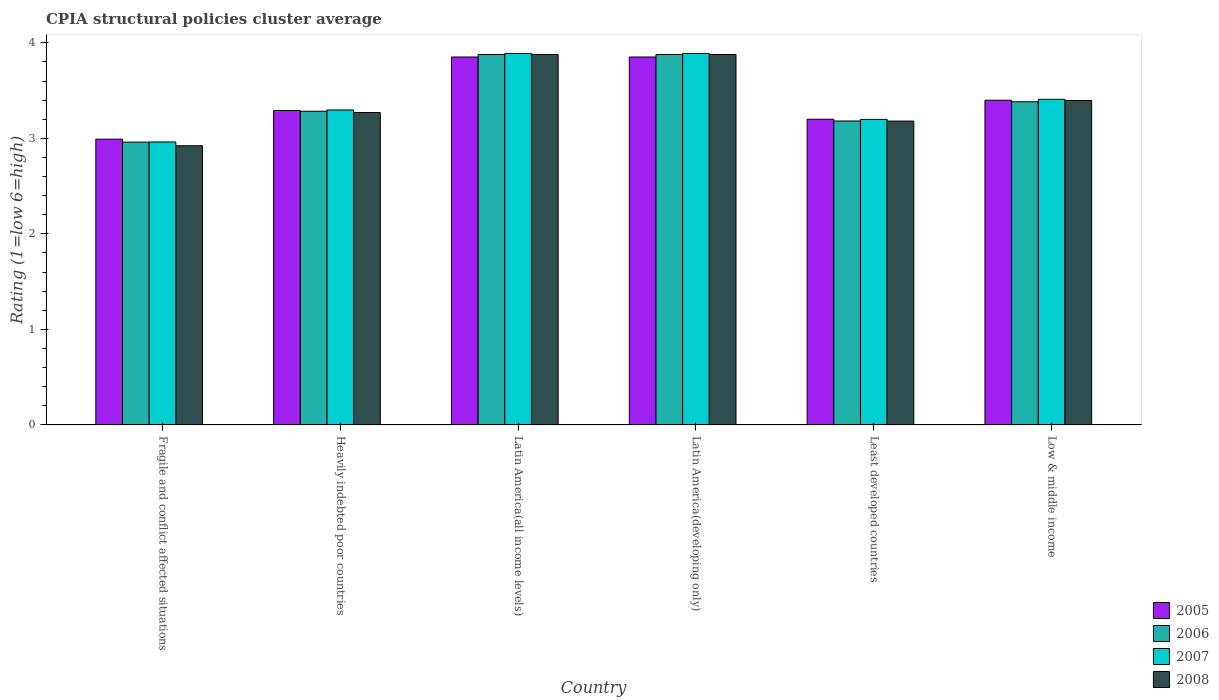How many different coloured bars are there?
Offer a terse response. 4. How many groups of bars are there?
Offer a very short reply. 6. Are the number of bars on each tick of the X-axis equal?
Ensure brevity in your answer.  Yes. How many bars are there on the 1st tick from the right?
Keep it short and to the point. 4. What is the label of the 4th group of bars from the left?
Make the answer very short. Latin America(developing only). In how many cases, is the number of bars for a given country not equal to the number of legend labels?
Provide a short and direct response. 0. What is the CPIA rating in 2007 in Latin America(developing only)?
Provide a short and direct response. 3.89. Across all countries, what is the maximum CPIA rating in 2006?
Offer a terse response. 3.88. Across all countries, what is the minimum CPIA rating in 2005?
Make the answer very short. 2.99. In which country was the CPIA rating in 2008 maximum?
Ensure brevity in your answer.  Latin America(all income levels). In which country was the CPIA rating in 2008 minimum?
Offer a very short reply. Fragile and conflict affected situations. What is the total CPIA rating in 2008 in the graph?
Ensure brevity in your answer.  20.53. What is the difference between the CPIA rating in 2006 in Fragile and conflict affected situations and that in Latin America(all income levels)?
Offer a terse response. -0.92. What is the difference between the CPIA rating in 2005 in Low & middle income and the CPIA rating in 2006 in Least developed countries?
Keep it short and to the point. 0.22. What is the average CPIA rating in 2007 per country?
Your answer should be very brief. 3.44. What is the difference between the CPIA rating of/in 2007 and CPIA rating of/in 2008 in Low & middle income?
Provide a succinct answer. 0.01. In how many countries, is the CPIA rating in 2008 greater than 2.2?
Make the answer very short. 6. What is the ratio of the CPIA rating in 2008 in Heavily indebted poor countries to that in Latin America(developing only)?
Offer a terse response. 0.84. Is the CPIA rating in 2008 in Least developed countries less than that in Low & middle income?
Your answer should be compact. Yes. What is the difference between the highest and the second highest CPIA rating in 2006?
Make the answer very short. -0.49. What is the difference between the highest and the lowest CPIA rating in 2007?
Offer a terse response. 0.93. In how many countries, is the CPIA rating in 2005 greater than the average CPIA rating in 2005 taken over all countries?
Offer a terse response. 2. What does the 2nd bar from the right in Heavily indebted poor countries represents?
Your answer should be very brief. 2007. How many bars are there?
Ensure brevity in your answer.  24. How many countries are there in the graph?
Offer a terse response. 6. Are the values on the major ticks of Y-axis written in scientific E-notation?
Keep it short and to the point. No. Does the graph contain grids?
Your answer should be very brief. No. What is the title of the graph?
Make the answer very short. CPIA structural policies cluster average. Does "2000" appear as one of the legend labels in the graph?
Provide a succinct answer. No. What is the label or title of the Y-axis?
Your response must be concise. Rating (1=low 6=high). What is the Rating (1=low 6=high) in 2005 in Fragile and conflict affected situations?
Make the answer very short. 2.99. What is the Rating (1=low 6=high) of 2006 in Fragile and conflict affected situations?
Give a very brief answer. 2.96. What is the Rating (1=low 6=high) of 2007 in Fragile and conflict affected situations?
Ensure brevity in your answer.  2.96. What is the Rating (1=low 6=high) of 2008 in Fragile and conflict affected situations?
Offer a very short reply. 2.92. What is the Rating (1=low 6=high) of 2005 in Heavily indebted poor countries?
Provide a succinct answer. 3.29. What is the Rating (1=low 6=high) of 2006 in Heavily indebted poor countries?
Ensure brevity in your answer.  3.28. What is the Rating (1=low 6=high) in 2007 in Heavily indebted poor countries?
Ensure brevity in your answer.  3.3. What is the Rating (1=low 6=high) in 2008 in Heavily indebted poor countries?
Ensure brevity in your answer.  3.27. What is the Rating (1=low 6=high) of 2005 in Latin America(all income levels)?
Your answer should be very brief. 3.85. What is the Rating (1=low 6=high) of 2006 in Latin America(all income levels)?
Ensure brevity in your answer.  3.88. What is the Rating (1=low 6=high) in 2007 in Latin America(all income levels)?
Your response must be concise. 3.89. What is the Rating (1=low 6=high) of 2008 in Latin America(all income levels)?
Your answer should be compact. 3.88. What is the Rating (1=low 6=high) in 2005 in Latin America(developing only)?
Your answer should be very brief. 3.85. What is the Rating (1=low 6=high) in 2006 in Latin America(developing only)?
Ensure brevity in your answer.  3.88. What is the Rating (1=low 6=high) in 2007 in Latin America(developing only)?
Make the answer very short. 3.89. What is the Rating (1=low 6=high) of 2008 in Latin America(developing only)?
Your answer should be very brief. 3.88. What is the Rating (1=low 6=high) of 2006 in Least developed countries?
Give a very brief answer. 3.18. What is the Rating (1=low 6=high) of 2007 in Least developed countries?
Ensure brevity in your answer.  3.2. What is the Rating (1=low 6=high) of 2008 in Least developed countries?
Your response must be concise. 3.18. What is the Rating (1=low 6=high) in 2005 in Low & middle income?
Provide a short and direct response. 3.4. What is the Rating (1=low 6=high) in 2006 in Low & middle income?
Give a very brief answer. 3.38. What is the Rating (1=low 6=high) in 2007 in Low & middle income?
Give a very brief answer. 3.41. What is the Rating (1=low 6=high) in 2008 in Low & middle income?
Your answer should be compact. 3.4. Across all countries, what is the maximum Rating (1=low 6=high) of 2005?
Keep it short and to the point. 3.85. Across all countries, what is the maximum Rating (1=low 6=high) of 2006?
Give a very brief answer. 3.88. Across all countries, what is the maximum Rating (1=low 6=high) of 2007?
Keep it short and to the point. 3.89. Across all countries, what is the maximum Rating (1=low 6=high) in 2008?
Keep it short and to the point. 3.88. Across all countries, what is the minimum Rating (1=low 6=high) of 2005?
Your answer should be compact. 2.99. Across all countries, what is the minimum Rating (1=low 6=high) of 2006?
Offer a terse response. 2.96. Across all countries, what is the minimum Rating (1=low 6=high) of 2007?
Your response must be concise. 2.96. Across all countries, what is the minimum Rating (1=low 6=high) in 2008?
Give a very brief answer. 2.92. What is the total Rating (1=low 6=high) of 2005 in the graph?
Ensure brevity in your answer.  20.59. What is the total Rating (1=low 6=high) in 2006 in the graph?
Provide a succinct answer. 20.56. What is the total Rating (1=low 6=high) of 2007 in the graph?
Offer a very short reply. 20.64. What is the total Rating (1=low 6=high) of 2008 in the graph?
Give a very brief answer. 20.53. What is the difference between the Rating (1=low 6=high) of 2005 in Fragile and conflict affected situations and that in Heavily indebted poor countries?
Your answer should be very brief. -0.3. What is the difference between the Rating (1=low 6=high) in 2006 in Fragile and conflict affected situations and that in Heavily indebted poor countries?
Offer a terse response. -0.32. What is the difference between the Rating (1=low 6=high) of 2007 in Fragile and conflict affected situations and that in Heavily indebted poor countries?
Make the answer very short. -0.34. What is the difference between the Rating (1=low 6=high) of 2008 in Fragile and conflict affected situations and that in Heavily indebted poor countries?
Provide a short and direct response. -0.35. What is the difference between the Rating (1=low 6=high) in 2005 in Fragile and conflict affected situations and that in Latin America(all income levels)?
Your answer should be very brief. -0.86. What is the difference between the Rating (1=low 6=high) of 2006 in Fragile and conflict affected situations and that in Latin America(all income levels)?
Make the answer very short. -0.92. What is the difference between the Rating (1=low 6=high) of 2007 in Fragile and conflict affected situations and that in Latin America(all income levels)?
Your answer should be very brief. -0.93. What is the difference between the Rating (1=low 6=high) in 2008 in Fragile and conflict affected situations and that in Latin America(all income levels)?
Keep it short and to the point. -0.96. What is the difference between the Rating (1=low 6=high) of 2005 in Fragile and conflict affected situations and that in Latin America(developing only)?
Provide a succinct answer. -0.86. What is the difference between the Rating (1=low 6=high) of 2006 in Fragile and conflict affected situations and that in Latin America(developing only)?
Your answer should be very brief. -0.92. What is the difference between the Rating (1=low 6=high) in 2007 in Fragile and conflict affected situations and that in Latin America(developing only)?
Your response must be concise. -0.93. What is the difference between the Rating (1=low 6=high) of 2008 in Fragile and conflict affected situations and that in Latin America(developing only)?
Your answer should be very brief. -0.96. What is the difference between the Rating (1=low 6=high) in 2005 in Fragile and conflict affected situations and that in Least developed countries?
Provide a succinct answer. -0.21. What is the difference between the Rating (1=low 6=high) in 2006 in Fragile and conflict affected situations and that in Least developed countries?
Your response must be concise. -0.22. What is the difference between the Rating (1=low 6=high) of 2007 in Fragile and conflict affected situations and that in Least developed countries?
Your answer should be compact. -0.24. What is the difference between the Rating (1=low 6=high) in 2008 in Fragile and conflict affected situations and that in Least developed countries?
Provide a short and direct response. -0.26. What is the difference between the Rating (1=low 6=high) of 2005 in Fragile and conflict affected situations and that in Low & middle income?
Offer a very short reply. -0.41. What is the difference between the Rating (1=low 6=high) of 2006 in Fragile and conflict affected situations and that in Low & middle income?
Your answer should be compact. -0.42. What is the difference between the Rating (1=low 6=high) in 2007 in Fragile and conflict affected situations and that in Low & middle income?
Your response must be concise. -0.45. What is the difference between the Rating (1=low 6=high) of 2008 in Fragile and conflict affected situations and that in Low & middle income?
Your answer should be very brief. -0.47. What is the difference between the Rating (1=low 6=high) of 2005 in Heavily indebted poor countries and that in Latin America(all income levels)?
Provide a short and direct response. -0.56. What is the difference between the Rating (1=low 6=high) in 2006 in Heavily indebted poor countries and that in Latin America(all income levels)?
Your answer should be very brief. -0.59. What is the difference between the Rating (1=low 6=high) in 2007 in Heavily indebted poor countries and that in Latin America(all income levels)?
Keep it short and to the point. -0.59. What is the difference between the Rating (1=low 6=high) in 2008 in Heavily indebted poor countries and that in Latin America(all income levels)?
Your answer should be compact. -0.61. What is the difference between the Rating (1=low 6=high) in 2005 in Heavily indebted poor countries and that in Latin America(developing only)?
Provide a short and direct response. -0.56. What is the difference between the Rating (1=low 6=high) of 2006 in Heavily indebted poor countries and that in Latin America(developing only)?
Offer a terse response. -0.59. What is the difference between the Rating (1=low 6=high) of 2007 in Heavily indebted poor countries and that in Latin America(developing only)?
Give a very brief answer. -0.59. What is the difference between the Rating (1=low 6=high) in 2008 in Heavily indebted poor countries and that in Latin America(developing only)?
Provide a succinct answer. -0.61. What is the difference between the Rating (1=low 6=high) of 2005 in Heavily indebted poor countries and that in Least developed countries?
Your answer should be very brief. 0.09. What is the difference between the Rating (1=low 6=high) of 2006 in Heavily indebted poor countries and that in Least developed countries?
Keep it short and to the point. 0.1. What is the difference between the Rating (1=low 6=high) in 2007 in Heavily indebted poor countries and that in Least developed countries?
Your answer should be very brief. 0.1. What is the difference between the Rating (1=low 6=high) of 2008 in Heavily indebted poor countries and that in Least developed countries?
Your response must be concise. 0.09. What is the difference between the Rating (1=low 6=high) of 2005 in Heavily indebted poor countries and that in Low & middle income?
Ensure brevity in your answer.  -0.11. What is the difference between the Rating (1=low 6=high) of 2006 in Heavily indebted poor countries and that in Low & middle income?
Make the answer very short. -0.1. What is the difference between the Rating (1=low 6=high) of 2007 in Heavily indebted poor countries and that in Low & middle income?
Offer a terse response. -0.11. What is the difference between the Rating (1=low 6=high) of 2008 in Heavily indebted poor countries and that in Low & middle income?
Offer a very short reply. -0.13. What is the difference between the Rating (1=low 6=high) in 2005 in Latin America(all income levels) and that in Latin America(developing only)?
Your answer should be very brief. 0. What is the difference between the Rating (1=low 6=high) in 2006 in Latin America(all income levels) and that in Latin America(developing only)?
Offer a very short reply. 0. What is the difference between the Rating (1=low 6=high) of 2007 in Latin America(all income levels) and that in Latin America(developing only)?
Offer a terse response. 0. What is the difference between the Rating (1=low 6=high) of 2008 in Latin America(all income levels) and that in Latin America(developing only)?
Offer a terse response. 0. What is the difference between the Rating (1=low 6=high) of 2005 in Latin America(all income levels) and that in Least developed countries?
Offer a very short reply. 0.65. What is the difference between the Rating (1=low 6=high) in 2006 in Latin America(all income levels) and that in Least developed countries?
Make the answer very short. 0.7. What is the difference between the Rating (1=low 6=high) in 2007 in Latin America(all income levels) and that in Least developed countries?
Ensure brevity in your answer.  0.69. What is the difference between the Rating (1=low 6=high) of 2008 in Latin America(all income levels) and that in Least developed countries?
Ensure brevity in your answer.  0.7. What is the difference between the Rating (1=low 6=high) of 2005 in Latin America(all income levels) and that in Low & middle income?
Provide a succinct answer. 0.45. What is the difference between the Rating (1=low 6=high) of 2006 in Latin America(all income levels) and that in Low & middle income?
Provide a short and direct response. 0.49. What is the difference between the Rating (1=low 6=high) in 2007 in Latin America(all income levels) and that in Low & middle income?
Offer a terse response. 0.48. What is the difference between the Rating (1=low 6=high) of 2008 in Latin America(all income levels) and that in Low & middle income?
Offer a terse response. 0.48. What is the difference between the Rating (1=low 6=high) in 2005 in Latin America(developing only) and that in Least developed countries?
Your answer should be very brief. 0.65. What is the difference between the Rating (1=low 6=high) of 2006 in Latin America(developing only) and that in Least developed countries?
Ensure brevity in your answer.  0.7. What is the difference between the Rating (1=low 6=high) in 2007 in Latin America(developing only) and that in Least developed countries?
Give a very brief answer. 0.69. What is the difference between the Rating (1=low 6=high) in 2008 in Latin America(developing only) and that in Least developed countries?
Keep it short and to the point. 0.7. What is the difference between the Rating (1=low 6=high) of 2005 in Latin America(developing only) and that in Low & middle income?
Your answer should be very brief. 0.45. What is the difference between the Rating (1=low 6=high) of 2006 in Latin America(developing only) and that in Low & middle income?
Offer a terse response. 0.49. What is the difference between the Rating (1=low 6=high) of 2007 in Latin America(developing only) and that in Low & middle income?
Your response must be concise. 0.48. What is the difference between the Rating (1=low 6=high) of 2008 in Latin America(developing only) and that in Low & middle income?
Keep it short and to the point. 0.48. What is the difference between the Rating (1=low 6=high) of 2005 in Least developed countries and that in Low & middle income?
Your answer should be compact. -0.2. What is the difference between the Rating (1=low 6=high) in 2006 in Least developed countries and that in Low & middle income?
Your answer should be very brief. -0.2. What is the difference between the Rating (1=low 6=high) of 2007 in Least developed countries and that in Low & middle income?
Keep it short and to the point. -0.21. What is the difference between the Rating (1=low 6=high) in 2008 in Least developed countries and that in Low & middle income?
Keep it short and to the point. -0.21. What is the difference between the Rating (1=low 6=high) in 2005 in Fragile and conflict affected situations and the Rating (1=low 6=high) in 2006 in Heavily indebted poor countries?
Offer a terse response. -0.29. What is the difference between the Rating (1=low 6=high) in 2005 in Fragile and conflict affected situations and the Rating (1=low 6=high) in 2007 in Heavily indebted poor countries?
Your answer should be very brief. -0.31. What is the difference between the Rating (1=low 6=high) of 2005 in Fragile and conflict affected situations and the Rating (1=low 6=high) of 2008 in Heavily indebted poor countries?
Ensure brevity in your answer.  -0.28. What is the difference between the Rating (1=low 6=high) of 2006 in Fragile and conflict affected situations and the Rating (1=low 6=high) of 2007 in Heavily indebted poor countries?
Provide a succinct answer. -0.34. What is the difference between the Rating (1=low 6=high) of 2006 in Fragile and conflict affected situations and the Rating (1=low 6=high) of 2008 in Heavily indebted poor countries?
Provide a succinct answer. -0.31. What is the difference between the Rating (1=low 6=high) of 2007 in Fragile and conflict affected situations and the Rating (1=low 6=high) of 2008 in Heavily indebted poor countries?
Keep it short and to the point. -0.31. What is the difference between the Rating (1=low 6=high) in 2005 in Fragile and conflict affected situations and the Rating (1=low 6=high) in 2006 in Latin America(all income levels)?
Keep it short and to the point. -0.89. What is the difference between the Rating (1=low 6=high) in 2005 in Fragile and conflict affected situations and the Rating (1=low 6=high) in 2007 in Latin America(all income levels)?
Keep it short and to the point. -0.9. What is the difference between the Rating (1=low 6=high) of 2005 in Fragile and conflict affected situations and the Rating (1=low 6=high) of 2008 in Latin America(all income levels)?
Give a very brief answer. -0.89. What is the difference between the Rating (1=low 6=high) in 2006 in Fragile and conflict affected situations and the Rating (1=low 6=high) in 2007 in Latin America(all income levels)?
Your answer should be very brief. -0.93. What is the difference between the Rating (1=low 6=high) of 2006 in Fragile and conflict affected situations and the Rating (1=low 6=high) of 2008 in Latin America(all income levels)?
Provide a short and direct response. -0.92. What is the difference between the Rating (1=low 6=high) in 2007 in Fragile and conflict affected situations and the Rating (1=low 6=high) in 2008 in Latin America(all income levels)?
Provide a succinct answer. -0.92. What is the difference between the Rating (1=low 6=high) in 2005 in Fragile and conflict affected situations and the Rating (1=low 6=high) in 2006 in Latin America(developing only)?
Offer a terse response. -0.89. What is the difference between the Rating (1=low 6=high) of 2005 in Fragile and conflict affected situations and the Rating (1=low 6=high) of 2007 in Latin America(developing only)?
Provide a succinct answer. -0.9. What is the difference between the Rating (1=low 6=high) of 2005 in Fragile and conflict affected situations and the Rating (1=low 6=high) of 2008 in Latin America(developing only)?
Provide a succinct answer. -0.89. What is the difference between the Rating (1=low 6=high) of 2006 in Fragile and conflict affected situations and the Rating (1=low 6=high) of 2007 in Latin America(developing only)?
Make the answer very short. -0.93. What is the difference between the Rating (1=low 6=high) of 2006 in Fragile and conflict affected situations and the Rating (1=low 6=high) of 2008 in Latin America(developing only)?
Provide a succinct answer. -0.92. What is the difference between the Rating (1=low 6=high) in 2007 in Fragile and conflict affected situations and the Rating (1=low 6=high) in 2008 in Latin America(developing only)?
Give a very brief answer. -0.92. What is the difference between the Rating (1=low 6=high) of 2005 in Fragile and conflict affected situations and the Rating (1=low 6=high) of 2006 in Least developed countries?
Your answer should be compact. -0.19. What is the difference between the Rating (1=low 6=high) of 2005 in Fragile and conflict affected situations and the Rating (1=low 6=high) of 2007 in Least developed countries?
Your answer should be very brief. -0.21. What is the difference between the Rating (1=low 6=high) in 2005 in Fragile and conflict affected situations and the Rating (1=low 6=high) in 2008 in Least developed countries?
Give a very brief answer. -0.19. What is the difference between the Rating (1=low 6=high) of 2006 in Fragile and conflict affected situations and the Rating (1=low 6=high) of 2007 in Least developed countries?
Offer a very short reply. -0.24. What is the difference between the Rating (1=low 6=high) in 2006 in Fragile and conflict affected situations and the Rating (1=low 6=high) in 2008 in Least developed countries?
Offer a terse response. -0.22. What is the difference between the Rating (1=low 6=high) of 2007 in Fragile and conflict affected situations and the Rating (1=low 6=high) of 2008 in Least developed countries?
Offer a terse response. -0.22. What is the difference between the Rating (1=low 6=high) of 2005 in Fragile and conflict affected situations and the Rating (1=low 6=high) of 2006 in Low & middle income?
Your response must be concise. -0.39. What is the difference between the Rating (1=low 6=high) in 2005 in Fragile and conflict affected situations and the Rating (1=low 6=high) in 2007 in Low & middle income?
Offer a very short reply. -0.42. What is the difference between the Rating (1=low 6=high) of 2005 in Fragile and conflict affected situations and the Rating (1=low 6=high) of 2008 in Low & middle income?
Your answer should be very brief. -0.4. What is the difference between the Rating (1=low 6=high) in 2006 in Fragile and conflict affected situations and the Rating (1=low 6=high) in 2007 in Low & middle income?
Keep it short and to the point. -0.45. What is the difference between the Rating (1=low 6=high) of 2006 in Fragile and conflict affected situations and the Rating (1=low 6=high) of 2008 in Low & middle income?
Your answer should be very brief. -0.44. What is the difference between the Rating (1=low 6=high) in 2007 in Fragile and conflict affected situations and the Rating (1=low 6=high) in 2008 in Low & middle income?
Your answer should be compact. -0.43. What is the difference between the Rating (1=low 6=high) of 2005 in Heavily indebted poor countries and the Rating (1=low 6=high) of 2006 in Latin America(all income levels)?
Provide a succinct answer. -0.59. What is the difference between the Rating (1=low 6=high) in 2005 in Heavily indebted poor countries and the Rating (1=low 6=high) in 2007 in Latin America(all income levels)?
Your answer should be compact. -0.6. What is the difference between the Rating (1=low 6=high) in 2005 in Heavily indebted poor countries and the Rating (1=low 6=high) in 2008 in Latin America(all income levels)?
Make the answer very short. -0.59. What is the difference between the Rating (1=low 6=high) in 2006 in Heavily indebted poor countries and the Rating (1=low 6=high) in 2007 in Latin America(all income levels)?
Provide a short and direct response. -0.61. What is the difference between the Rating (1=low 6=high) of 2006 in Heavily indebted poor countries and the Rating (1=low 6=high) of 2008 in Latin America(all income levels)?
Offer a terse response. -0.59. What is the difference between the Rating (1=low 6=high) of 2007 in Heavily indebted poor countries and the Rating (1=low 6=high) of 2008 in Latin America(all income levels)?
Your response must be concise. -0.58. What is the difference between the Rating (1=low 6=high) in 2005 in Heavily indebted poor countries and the Rating (1=low 6=high) in 2006 in Latin America(developing only)?
Your answer should be very brief. -0.59. What is the difference between the Rating (1=low 6=high) of 2005 in Heavily indebted poor countries and the Rating (1=low 6=high) of 2007 in Latin America(developing only)?
Ensure brevity in your answer.  -0.6. What is the difference between the Rating (1=low 6=high) in 2005 in Heavily indebted poor countries and the Rating (1=low 6=high) in 2008 in Latin America(developing only)?
Your answer should be very brief. -0.59. What is the difference between the Rating (1=low 6=high) of 2006 in Heavily indebted poor countries and the Rating (1=low 6=high) of 2007 in Latin America(developing only)?
Ensure brevity in your answer.  -0.61. What is the difference between the Rating (1=low 6=high) in 2006 in Heavily indebted poor countries and the Rating (1=low 6=high) in 2008 in Latin America(developing only)?
Ensure brevity in your answer.  -0.59. What is the difference between the Rating (1=low 6=high) in 2007 in Heavily indebted poor countries and the Rating (1=low 6=high) in 2008 in Latin America(developing only)?
Give a very brief answer. -0.58. What is the difference between the Rating (1=low 6=high) of 2005 in Heavily indebted poor countries and the Rating (1=low 6=high) of 2006 in Least developed countries?
Make the answer very short. 0.11. What is the difference between the Rating (1=low 6=high) of 2005 in Heavily indebted poor countries and the Rating (1=low 6=high) of 2007 in Least developed countries?
Offer a very short reply. 0.09. What is the difference between the Rating (1=low 6=high) of 2005 in Heavily indebted poor countries and the Rating (1=low 6=high) of 2008 in Least developed countries?
Keep it short and to the point. 0.11. What is the difference between the Rating (1=low 6=high) in 2006 in Heavily indebted poor countries and the Rating (1=low 6=high) in 2007 in Least developed countries?
Keep it short and to the point. 0.09. What is the difference between the Rating (1=low 6=high) of 2006 in Heavily indebted poor countries and the Rating (1=low 6=high) of 2008 in Least developed countries?
Make the answer very short. 0.1. What is the difference between the Rating (1=low 6=high) in 2007 in Heavily indebted poor countries and the Rating (1=low 6=high) in 2008 in Least developed countries?
Make the answer very short. 0.12. What is the difference between the Rating (1=low 6=high) in 2005 in Heavily indebted poor countries and the Rating (1=low 6=high) in 2006 in Low & middle income?
Provide a succinct answer. -0.09. What is the difference between the Rating (1=low 6=high) in 2005 in Heavily indebted poor countries and the Rating (1=low 6=high) in 2007 in Low & middle income?
Your answer should be very brief. -0.12. What is the difference between the Rating (1=low 6=high) in 2005 in Heavily indebted poor countries and the Rating (1=low 6=high) in 2008 in Low & middle income?
Your answer should be very brief. -0.1. What is the difference between the Rating (1=low 6=high) in 2006 in Heavily indebted poor countries and the Rating (1=low 6=high) in 2007 in Low & middle income?
Provide a succinct answer. -0.13. What is the difference between the Rating (1=low 6=high) of 2006 in Heavily indebted poor countries and the Rating (1=low 6=high) of 2008 in Low & middle income?
Provide a short and direct response. -0.11. What is the difference between the Rating (1=low 6=high) in 2007 in Heavily indebted poor countries and the Rating (1=low 6=high) in 2008 in Low & middle income?
Offer a terse response. -0.1. What is the difference between the Rating (1=low 6=high) in 2005 in Latin America(all income levels) and the Rating (1=low 6=high) in 2006 in Latin America(developing only)?
Provide a short and direct response. -0.03. What is the difference between the Rating (1=low 6=high) of 2005 in Latin America(all income levels) and the Rating (1=low 6=high) of 2007 in Latin America(developing only)?
Provide a short and direct response. -0.04. What is the difference between the Rating (1=low 6=high) of 2005 in Latin America(all income levels) and the Rating (1=low 6=high) of 2008 in Latin America(developing only)?
Your answer should be very brief. -0.03. What is the difference between the Rating (1=low 6=high) in 2006 in Latin America(all income levels) and the Rating (1=low 6=high) in 2007 in Latin America(developing only)?
Ensure brevity in your answer.  -0.01. What is the difference between the Rating (1=low 6=high) of 2006 in Latin America(all income levels) and the Rating (1=low 6=high) of 2008 in Latin America(developing only)?
Your answer should be very brief. 0. What is the difference between the Rating (1=low 6=high) of 2007 in Latin America(all income levels) and the Rating (1=low 6=high) of 2008 in Latin America(developing only)?
Ensure brevity in your answer.  0.01. What is the difference between the Rating (1=low 6=high) in 2005 in Latin America(all income levels) and the Rating (1=low 6=high) in 2006 in Least developed countries?
Your answer should be compact. 0.67. What is the difference between the Rating (1=low 6=high) of 2005 in Latin America(all income levels) and the Rating (1=low 6=high) of 2007 in Least developed countries?
Make the answer very short. 0.65. What is the difference between the Rating (1=low 6=high) in 2005 in Latin America(all income levels) and the Rating (1=low 6=high) in 2008 in Least developed countries?
Your answer should be compact. 0.67. What is the difference between the Rating (1=low 6=high) in 2006 in Latin America(all income levels) and the Rating (1=low 6=high) in 2007 in Least developed countries?
Provide a succinct answer. 0.68. What is the difference between the Rating (1=low 6=high) in 2006 in Latin America(all income levels) and the Rating (1=low 6=high) in 2008 in Least developed countries?
Ensure brevity in your answer.  0.7. What is the difference between the Rating (1=low 6=high) in 2007 in Latin America(all income levels) and the Rating (1=low 6=high) in 2008 in Least developed countries?
Keep it short and to the point. 0.71. What is the difference between the Rating (1=low 6=high) in 2005 in Latin America(all income levels) and the Rating (1=low 6=high) in 2006 in Low & middle income?
Your answer should be very brief. 0.47. What is the difference between the Rating (1=low 6=high) of 2005 in Latin America(all income levels) and the Rating (1=low 6=high) of 2007 in Low & middle income?
Make the answer very short. 0.44. What is the difference between the Rating (1=low 6=high) of 2005 in Latin America(all income levels) and the Rating (1=low 6=high) of 2008 in Low & middle income?
Your answer should be compact. 0.46. What is the difference between the Rating (1=low 6=high) in 2006 in Latin America(all income levels) and the Rating (1=low 6=high) in 2007 in Low & middle income?
Keep it short and to the point. 0.47. What is the difference between the Rating (1=low 6=high) of 2006 in Latin America(all income levels) and the Rating (1=low 6=high) of 2008 in Low & middle income?
Your answer should be compact. 0.48. What is the difference between the Rating (1=low 6=high) of 2007 in Latin America(all income levels) and the Rating (1=low 6=high) of 2008 in Low & middle income?
Offer a terse response. 0.49. What is the difference between the Rating (1=low 6=high) of 2005 in Latin America(developing only) and the Rating (1=low 6=high) of 2006 in Least developed countries?
Offer a terse response. 0.67. What is the difference between the Rating (1=low 6=high) of 2005 in Latin America(developing only) and the Rating (1=low 6=high) of 2007 in Least developed countries?
Offer a terse response. 0.65. What is the difference between the Rating (1=low 6=high) in 2005 in Latin America(developing only) and the Rating (1=low 6=high) in 2008 in Least developed countries?
Ensure brevity in your answer.  0.67. What is the difference between the Rating (1=low 6=high) of 2006 in Latin America(developing only) and the Rating (1=low 6=high) of 2007 in Least developed countries?
Offer a very short reply. 0.68. What is the difference between the Rating (1=low 6=high) of 2006 in Latin America(developing only) and the Rating (1=low 6=high) of 2008 in Least developed countries?
Provide a short and direct response. 0.7. What is the difference between the Rating (1=low 6=high) in 2007 in Latin America(developing only) and the Rating (1=low 6=high) in 2008 in Least developed countries?
Provide a short and direct response. 0.71. What is the difference between the Rating (1=low 6=high) in 2005 in Latin America(developing only) and the Rating (1=low 6=high) in 2006 in Low & middle income?
Your answer should be compact. 0.47. What is the difference between the Rating (1=low 6=high) of 2005 in Latin America(developing only) and the Rating (1=low 6=high) of 2007 in Low & middle income?
Provide a succinct answer. 0.44. What is the difference between the Rating (1=low 6=high) of 2005 in Latin America(developing only) and the Rating (1=low 6=high) of 2008 in Low & middle income?
Provide a short and direct response. 0.46. What is the difference between the Rating (1=low 6=high) in 2006 in Latin America(developing only) and the Rating (1=low 6=high) in 2007 in Low & middle income?
Your answer should be very brief. 0.47. What is the difference between the Rating (1=low 6=high) in 2006 in Latin America(developing only) and the Rating (1=low 6=high) in 2008 in Low & middle income?
Ensure brevity in your answer.  0.48. What is the difference between the Rating (1=low 6=high) of 2007 in Latin America(developing only) and the Rating (1=low 6=high) of 2008 in Low & middle income?
Make the answer very short. 0.49. What is the difference between the Rating (1=low 6=high) in 2005 in Least developed countries and the Rating (1=low 6=high) in 2006 in Low & middle income?
Ensure brevity in your answer.  -0.18. What is the difference between the Rating (1=low 6=high) in 2005 in Least developed countries and the Rating (1=low 6=high) in 2007 in Low & middle income?
Offer a terse response. -0.21. What is the difference between the Rating (1=low 6=high) in 2005 in Least developed countries and the Rating (1=low 6=high) in 2008 in Low & middle income?
Ensure brevity in your answer.  -0.2. What is the difference between the Rating (1=low 6=high) in 2006 in Least developed countries and the Rating (1=low 6=high) in 2007 in Low & middle income?
Your response must be concise. -0.23. What is the difference between the Rating (1=low 6=high) of 2006 in Least developed countries and the Rating (1=low 6=high) of 2008 in Low & middle income?
Provide a short and direct response. -0.21. What is the difference between the Rating (1=low 6=high) in 2007 in Least developed countries and the Rating (1=low 6=high) in 2008 in Low & middle income?
Ensure brevity in your answer.  -0.2. What is the average Rating (1=low 6=high) in 2005 per country?
Your answer should be very brief. 3.43. What is the average Rating (1=low 6=high) in 2006 per country?
Your answer should be compact. 3.43. What is the average Rating (1=low 6=high) of 2007 per country?
Make the answer very short. 3.44. What is the average Rating (1=low 6=high) in 2008 per country?
Provide a short and direct response. 3.42. What is the difference between the Rating (1=low 6=high) of 2005 and Rating (1=low 6=high) of 2006 in Fragile and conflict affected situations?
Offer a terse response. 0.03. What is the difference between the Rating (1=low 6=high) in 2005 and Rating (1=low 6=high) in 2007 in Fragile and conflict affected situations?
Offer a very short reply. 0.03. What is the difference between the Rating (1=low 6=high) in 2005 and Rating (1=low 6=high) in 2008 in Fragile and conflict affected situations?
Your response must be concise. 0.07. What is the difference between the Rating (1=low 6=high) of 2006 and Rating (1=low 6=high) of 2007 in Fragile and conflict affected situations?
Keep it short and to the point. -0. What is the difference between the Rating (1=low 6=high) of 2006 and Rating (1=low 6=high) of 2008 in Fragile and conflict affected situations?
Your answer should be compact. 0.04. What is the difference between the Rating (1=low 6=high) of 2007 and Rating (1=low 6=high) of 2008 in Fragile and conflict affected situations?
Offer a terse response. 0.04. What is the difference between the Rating (1=low 6=high) of 2005 and Rating (1=low 6=high) of 2006 in Heavily indebted poor countries?
Make the answer very short. 0.01. What is the difference between the Rating (1=low 6=high) of 2005 and Rating (1=low 6=high) of 2007 in Heavily indebted poor countries?
Provide a short and direct response. -0.01. What is the difference between the Rating (1=low 6=high) in 2005 and Rating (1=low 6=high) in 2008 in Heavily indebted poor countries?
Your answer should be very brief. 0.02. What is the difference between the Rating (1=low 6=high) of 2006 and Rating (1=low 6=high) of 2007 in Heavily indebted poor countries?
Ensure brevity in your answer.  -0.01. What is the difference between the Rating (1=low 6=high) of 2006 and Rating (1=low 6=high) of 2008 in Heavily indebted poor countries?
Your response must be concise. 0.01. What is the difference between the Rating (1=low 6=high) in 2007 and Rating (1=low 6=high) in 2008 in Heavily indebted poor countries?
Your answer should be very brief. 0.03. What is the difference between the Rating (1=low 6=high) of 2005 and Rating (1=low 6=high) of 2006 in Latin America(all income levels)?
Your answer should be compact. -0.03. What is the difference between the Rating (1=low 6=high) of 2005 and Rating (1=low 6=high) of 2007 in Latin America(all income levels)?
Keep it short and to the point. -0.04. What is the difference between the Rating (1=low 6=high) of 2005 and Rating (1=low 6=high) of 2008 in Latin America(all income levels)?
Keep it short and to the point. -0.03. What is the difference between the Rating (1=low 6=high) in 2006 and Rating (1=low 6=high) in 2007 in Latin America(all income levels)?
Keep it short and to the point. -0.01. What is the difference between the Rating (1=low 6=high) of 2006 and Rating (1=low 6=high) of 2008 in Latin America(all income levels)?
Ensure brevity in your answer.  0. What is the difference between the Rating (1=low 6=high) of 2007 and Rating (1=low 6=high) of 2008 in Latin America(all income levels)?
Your answer should be very brief. 0.01. What is the difference between the Rating (1=low 6=high) of 2005 and Rating (1=low 6=high) of 2006 in Latin America(developing only)?
Make the answer very short. -0.03. What is the difference between the Rating (1=low 6=high) in 2005 and Rating (1=low 6=high) in 2007 in Latin America(developing only)?
Your response must be concise. -0.04. What is the difference between the Rating (1=low 6=high) in 2005 and Rating (1=low 6=high) in 2008 in Latin America(developing only)?
Keep it short and to the point. -0.03. What is the difference between the Rating (1=low 6=high) of 2006 and Rating (1=low 6=high) of 2007 in Latin America(developing only)?
Offer a terse response. -0.01. What is the difference between the Rating (1=low 6=high) in 2006 and Rating (1=low 6=high) in 2008 in Latin America(developing only)?
Your answer should be very brief. 0. What is the difference between the Rating (1=low 6=high) of 2007 and Rating (1=low 6=high) of 2008 in Latin America(developing only)?
Provide a short and direct response. 0.01. What is the difference between the Rating (1=low 6=high) of 2005 and Rating (1=low 6=high) of 2006 in Least developed countries?
Give a very brief answer. 0.02. What is the difference between the Rating (1=low 6=high) of 2005 and Rating (1=low 6=high) of 2007 in Least developed countries?
Your response must be concise. 0. What is the difference between the Rating (1=low 6=high) in 2005 and Rating (1=low 6=high) in 2008 in Least developed countries?
Provide a succinct answer. 0.02. What is the difference between the Rating (1=low 6=high) of 2006 and Rating (1=low 6=high) of 2007 in Least developed countries?
Make the answer very short. -0.02. What is the difference between the Rating (1=low 6=high) in 2006 and Rating (1=low 6=high) in 2008 in Least developed countries?
Keep it short and to the point. 0. What is the difference between the Rating (1=low 6=high) of 2007 and Rating (1=low 6=high) of 2008 in Least developed countries?
Ensure brevity in your answer.  0.02. What is the difference between the Rating (1=low 6=high) of 2005 and Rating (1=low 6=high) of 2006 in Low & middle income?
Offer a very short reply. 0.02. What is the difference between the Rating (1=low 6=high) of 2005 and Rating (1=low 6=high) of 2007 in Low & middle income?
Ensure brevity in your answer.  -0.01. What is the difference between the Rating (1=low 6=high) of 2005 and Rating (1=low 6=high) of 2008 in Low & middle income?
Your answer should be very brief. 0. What is the difference between the Rating (1=low 6=high) in 2006 and Rating (1=low 6=high) in 2007 in Low & middle income?
Your answer should be very brief. -0.03. What is the difference between the Rating (1=low 6=high) of 2006 and Rating (1=low 6=high) of 2008 in Low & middle income?
Provide a succinct answer. -0.01. What is the difference between the Rating (1=low 6=high) in 2007 and Rating (1=low 6=high) in 2008 in Low & middle income?
Offer a very short reply. 0.01. What is the ratio of the Rating (1=low 6=high) in 2005 in Fragile and conflict affected situations to that in Heavily indebted poor countries?
Your response must be concise. 0.91. What is the ratio of the Rating (1=low 6=high) of 2006 in Fragile and conflict affected situations to that in Heavily indebted poor countries?
Offer a very short reply. 0.9. What is the ratio of the Rating (1=low 6=high) in 2007 in Fragile and conflict affected situations to that in Heavily indebted poor countries?
Provide a short and direct response. 0.9. What is the ratio of the Rating (1=low 6=high) of 2008 in Fragile and conflict affected situations to that in Heavily indebted poor countries?
Your answer should be very brief. 0.89. What is the ratio of the Rating (1=low 6=high) in 2005 in Fragile and conflict affected situations to that in Latin America(all income levels)?
Your answer should be very brief. 0.78. What is the ratio of the Rating (1=low 6=high) of 2006 in Fragile and conflict affected situations to that in Latin America(all income levels)?
Provide a succinct answer. 0.76. What is the ratio of the Rating (1=low 6=high) in 2007 in Fragile and conflict affected situations to that in Latin America(all income levels)?
Offer a terse response. 0.76. What is the ratio of the Rating (1=low 6=high) of 2008 in Fragile and conflict affected situations to that in Latin America(all income levels)?
Your answer should be very brief. 0.75. What is the ratio of the Rating (1=low 6=high) of 2005 in Fragile and conflict affected situations to that in Latin America(developing only)?
Ensure brevity in your answer.  0.78. What is the ratio of the Rating (1=low 6=high) in 2006 in Fragile and conflict affected situations to that in Latin America(developing only)?
Your response must be concise. 0.76. What is the ratio of the Rating (1=low 6=high) in 2007 in Fragile and conflict affected situations to that in Latin America(developing only)?
Ensure brevity in your answer.  0.76. What is the ratio of the Rating (1=low 6=high) in 2008 in Fragile and conflict affected situations to that in Latin America(developing only)?
Your answer should be very brief. 0.75. What is the ratio of the Rating (1=low 6=high) in 2005 in Fragile and conflict affected situations to that in Least developed countries?
Provide a short and direct response. 0.93. What is the ratio of the Rating (1=low 6=high) of 2006 in Fragile and conflict affected situations to that in Least developed countries?
Make the answer very short. 0.93. What is the ratio of the Rating (1=low 6=high) of 2007 in Fragile and conflict affected situations to that in Least developed countries?
Provide a short and direct response. 0.93. What is the ratio of the Rating (1=low 6=high) in 2008 in Fragile and conflict affected situations to that in Least developed countries?
Make the answer very short. 0.92. What is the ratio of the Rating (1=low 6=high) of 2005 in Fragile and conflict affected situations to that in Low & middle income?
Your answer should be compact. 0.88. What is the ratio of the Rating (1=low 6=high) in 2006 in Fragile and conflict affected situations to that in Low & middle income?
Your response must be concise. 0.88. What is the ratio of the Rating (1=low 6=high) of 2007 in Fragile and conflict affected situations to that in Low & middle income?
Keep it short and to the point. 0.87. What is the ratio of the Rating (1=low 6=high) of 2008 in Fragile and conflict affected situations to that in Low & middle income?
Provide a short and direct response. 0.86. What is the ratio of the Rating (1=low 6=high) in 2005 in Heavily indebted poor countries to that in Latin America(all income levels)?
Your response must be concise. 0.85. What is the ratio of the Rating (1=low 6=high) of 2006 in Heavily indebted poor countries to that in Latin America(all income levels)?
Provide a succinct answer. 0.85. What is the ratio of the Rating (1=low 6=high) in 2007 in Heavily indebted poor countries to that in Latin America(all income levels)?
Offer a very short reply. 0.85. What is the ratio of the Rating (1=low 6=high) in 2008 in Heavily indebted poor countries to that in Latin America(all income levels)?
Your answer should be compact. 0.84. What is the ratio of the Rating (1=low 6=high) of 2005 in Heavily indebted poor countries to that in Latin America(developing only)?
Provide a short and direct response. 0.85. What is the ratio of the Rating (1=low 6=high) of 2006 in Heavily indebted poor countries to that in Latin America(developing only)?
Ensure brevity in your answer.  0.85. What is the ratio of the Rating (1=low 6=high) of 2007 in Heavily indebted poor countries to that in Latin America(developing only)?
Your answer should be very brief. 0.85. What is the ratio of the Rating (1=low 6=high) of 2008 in Heavily indebted poor countries to that in Latin America(developing only)?
Provide a short and direct response. 0.84. What is the ratio of the Rating (1=low 6=high) in 2005 in Heavily indebted poor countries to that in Least developed countries?
Ensure brevity in your answer.  1.03. What is the ratio of the Rating (1=low 6=high) of 2006 in Heavily indebted poor countries to that in Least developed countries?
Ensure brevity in your answer.  1.03. What is the ratio of the Rating (1=low 6=high) in 2007 in Heavily indebted poor countries to that in Least developed countries?
Your answer should be very brief. 1.03. What is the ratio of the Rating (1=low 6=high) in 2008 in Heavily indebted poor countries to that in Least developed countries?
Keep it short and to the point. 1.03. What is the ratio of the Rating (1=low 6=high) of 2005 in Heavily indebted poor countries to that in Low & middle income?
Ensure brevity in your answer.  0.97. What is the ratio of the Rating (1=low 6=high) in 2006 in Heavily indebted poor countries to that in Low & middle income?
Make the answer very short. 0.97. What is the ratio of the Rating (1=low 6=high) in 2007 in Heavily indebted poor countries to that in Low & middle income?
Give a very brief answer. 0.97. What is the ratio of the Rating (1=low 6=high) in 2005 in Latin America(all income levels) to that in Least developed countries?
Provide a succinct answer. 1.2. What is the ratio of the Rating (1=low 6=high) in 2006 in Latin America(all income levels) to that in Least developed countries?
Your answer should be compact. 1.22. What is the ratio of the Rating (1=low 6=high) in 2007 in Latin America(all income levels) to that in Least developed countries?
Provide a short and direct response. 1.22. What is the ratio of the Rating (1=low 6=high) of 2008 in Latin America(all income levels) to that in Least developed countries?
Your response must be concise. 1.22. What is the ratio of the Rating (1=low 6=high) of 2005 in Latin America(all income levels) to that in Low & middle income?
Your answer should be very brief. 1.13. What is the ratio of the Rating (1=low 6=high) of 2006 in Latin America(all income levels) to that in Low & middle income?
Your answer should be very brief. 1.15. What is the ratio of the Rating (1=low 6=high) in 2007 in Latin America(all income levels) to that in Low & middle income?
Provide a succinct answer. 1.14. What is the ratio of the Rating (1=low 6=high) of 2008 in Latin America(all income levels) to that in Low & middle income?
Ensure brevity in your answer.  1.14. What is the ratio of the Rating (1=low 6=high) in 2005 in Latin America(developing only) to that in Least developed countries?
Offer a terse response. 1.2. What is the ratio of the Rating (1=low 6=high) in 2006 in Latin America(developing only) to that in Least developed countries?
Give a very brief answer. 1.22. What is the ratio of the Rating (1=low 6=high) in 2007 in Latin America(developing only) to that in Least developed countries?
Provide a succinct answer. 1.22. What is the ratio of the Rating (1=low 6=high) of 2008 in Latin America(developing only) to that in Least developed countries?
Offer a terse response. 1.22. What is the ratio of the Rating (1=low 6=high) in 2005 in Latin America(developing only) to that in Low & middle income?
Ensure brevity in your answer.  1.13. What is the ratio of the Rating (1=low 6=high) in 2006 in Latin America(developing only) to that in Low & middle income?
Your answer should be compact. 1.15. What is the ratio of the Rating (1=low 6=high) in 2007 in Latin America(developing only) to that in Low & middle income?
Give a very brief answer. 1.14. What is the ratio of the Rating (1=low 6=high) of 2008 in Latin America(developing only) to that in Low & middle income?
Offer a very short reply. 1.14. What is the ratio of the Rating (1=low 6=high) in 2005 in Least developed countries to that in Low & middle income?
Offer a very short reply. 0.94. What is the ratio of the Rating (1=low 6=high) of 2006 in Least developed countries to that in Low & middle income?
Give a very brief answer. 0.94. What is the ratio of the Rating (1=low 6=high) of 2007 in Least developed countries to that in Low & middle income?
Ensure brevity in your answer.  0.94. What is the ratio of the Rating (1=low 6=high) in 2008 in Least developed countries to that in Low & middle income?
Your answer should be very brief. 0.94. What is the difference between the highest and the second highest Rating (1=low 6=high) in 2005?
Keep it short and to the point. 0. What is the difference between the highest and the second highest Rating (1=low 6=high) of 2007?
Provide a succinct answer. 0. What is the difference between the highest and the lowest Rating (1=low 6=high) of 2005?
Provide a short and direct response. 0.86. What is the difference between the highest and the lowest Rating (1=low 6=high) in 2006?
Provide a succinct answer. 0.92. What is the difference between the highest and the lowest Rating (1=low 6=high) in 2007?
Provide a succinct answer. 0.93. What is the difference between the highest and the lowest Rating (1=low 6=high) in 2008?
Provide a short and direct response. 0.96. 